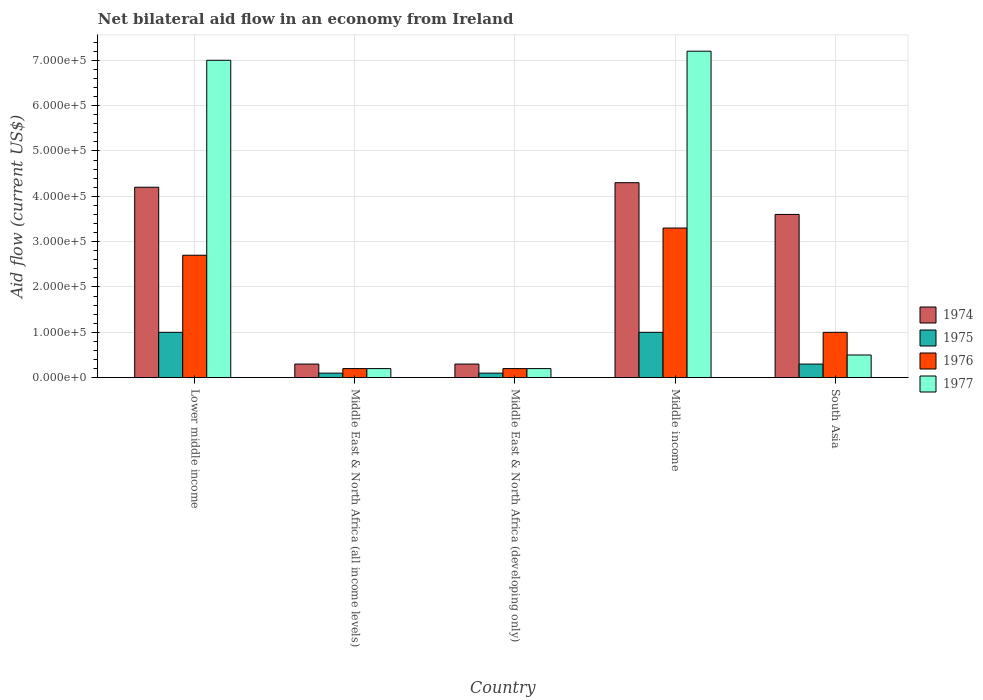How many groups of bars are there?
Provide a succinct answer. 5. Are the number of bars per tick equal to the number of legend labels?
Offer a terse response. Yes. Are the number of bars on each tick of the X-axis equal?
Provide a short and direct response. Yes. How many bars are there on the 5th tick from the left?
Your response must be concise. 4. How many bars are there on the 4th tick from the right?
Offer a very short reply. 4. What is the label of the 2nd group of bars from the left?
Offer a very short reply. Middle East & North Africa (all income levels). Across all countries, what is the maximum net bilateral aid flow in 1976?
Make the answer very short. 3.30e+05. Across all countries, what is the minimum net bilateral aid flow in 1977?
Your answer should be very brief. 2.00e+04. In which country was the net bilateral aid flow in 1975 maximum?
Ensure brevity in your answer.  Lower middle income. In which country was the net bilateral aid flow in 1975 minimum?
Ensure brevity in your answer.  Middle East & North Africa (all income levels). What is the total net bilateral aid flow in 1977 in the graph?
Your response must be concise. 1.51e+06. What is the difference between the net bilateral aid flow in 1977 in Middle East & North Africa (all income levels) and that in Middle income?
Your answer should be very brief. -7.00e+05. What is the difference between the net bilateral aid flow in 1975 in South Asia and the net bilateral aid flow in 1977 in Middle income?
Your answer should be compact. -6.90e+05. What is the average net bilateral aid flow in 1974 per country?
Make the answer very short. 2.54e+05. In how many countries, is the net bilateral aid flow in 1976 greater than 480000 US$?
Offer a terse response. 0. Is the net bilateral aid flow in 1976 in Lower middle income less than that in Middle East & North Africa (developing only)?
Provide a succinct answer. No. What is the difference between the highest and the second highest net bilateral aid flow in 1977?
Offer a terse response. 6.70e+05. Is it the case that in every country, the sum of the net bilateral aid flow in 1975 and net bilateral aid flow in 1977 is greater than the sum of net bilateral aid flow in 1974 and net bilateral aid flow in 1976?
Your answer should be compact. No. What does the 1st bar from the left in Middle East & North Africa (developing only) represents?
Your answer should be compact. 1974. How many bars are there?
Your answer should be very brief. 20. Are all the bars in the graph horizontal?
Ensure brevity in your answer.  No. How many countries are there in the graph?
Provide a short and direct response. 5. What is the difference between two consecutive major ticks on the Y-axis?
Provide a short and direct response. 1.00e+05. Does the graph contain any zero values?
Ensure brevity in your answer.  No. Where does the legend appear in the graph?
Give a very brief answer. Center right. What is the title of the graph?
Give a very brief answer. Net bilateral aid flow in an economy from Ireland. Does "1981" appear as one of the legend labels in the graph?
Your answer should be very brief. No. What is the Aid flow (current US$) in 1975 in Lower middle income?
Offer a very short reply. 1.00e+05. What is the Aid flow (current US$) in 1976 in Lower middle income?
Offer a very short reply. 2.70e+05. What is the Aid flow (current US$) of 1974 in Middle East & North Africa (all income levels)?
Ensure brevity in your answer.  3.00e+04. What is the Aid flow (current US$) of 1975 in Middle East & North Africa (all income levels)?
Provide a short and direct response. 10000. What is the Aid flow (current US$) of 1974 in Middle East & North Africa (developing only)?
Your response must be concise. 3.00e+04. What is the Aid flow (current US$) in 1975 in Middle East & North Africa (developing only)?
Keep it short and to the point. 10000. What is the Aid flow (current US$) of 1976 in Middle East & North Africa (developing only)?
Offer a terse response. 2.00e+04. What is the Aid flow (current US$) of 1977 in Middle East & North Africa (developing only)?
Make the answer very short. 2.00e+04. What is the Aid flow (current US$) in 1975 in Middle income?
Ensure brevity in your answer.  1.00e+05. What is the Aid flow (current US$) of 1977 in Middle income?
Keep it short and to the point. 7.20e+05. What is the Aid flow (current US$) of 1976 in South Asia?
Give a very brief answer. 1.00e+05. Across all countries, what is the maximum Aid flow (current US$) of 1974?
Keep it short and to the point. 4.30e+05. Across all countries, what is the maximum Aid flow (current US$) of 1975?
Offer a very short reply. 1.00e+05. Across all countries, what is the maximum Aid flow (current US$) of 1977?
Your answer should be very brief. 7.20e+05. Across all countries, what is the minimum Aid flow (current US$) of 1975?
Your response must be concise. 10000. Across all countries, what is the minimum Aid flow (current US$) in 1977?
Your answer should be very brief. 2.00e+04. What is the total Aid flow (current US$) of 1974 in the graph?
Your response must be concise. 1.27e+06. What is the total Aid flow (current US$) in 1976 in the graph?
Provide a succinct answer. 7.40e+05. What is the total Aid flow (current US$) in 1977 in the graph?
Keep it short and to the point. 1.51e+06. What is the difference between the Aid flow (current US$) in 1974 in Lower middle income and that in Middle East & North Africa (all income levels)?
Your response must be concise. 3.90e+05. What is the difference between the Aid flow (current US$) of 1975 in Lower middle income and that in Middle East & North Africa (all income levels)?
Keep it short and to the point. 9.00e+04. What is the difference between the Aid flow (current US$) of 1976 in Lower middle income and that in Middle East & North Africa (all income levels)?
Your answer should be very brief. 2.50e+05. What is the difference between the Aid flow (current US$) of 1977 in Lower middle income and that in Middle East & North Africa (all income levels)?
Your answer should be very brief. 6.80e+05. What is the difference between the Aid flow (current US$) of 1977 in Lower middle income and that in Middle East & North Africa (developing only)?
Ensure brevity in your answer.  6.80e+05. What is the difference between the Aid flow (current US$) of 1977 in Lower middle income and that in Middle income?
Provide a succinct answer. -2.00e+04. What is the difference between the Aid flow (current US$) of 1974 in Lower middle income and that in South Asia?
Provide a short and direct response. 6.00e+04. What is the difference between the Aid flow (current US$) of 1976 in Lower middle income and that in South Asia?
Make the answer very short. 1.70e+05. What is the difference between the Aid flow (current US$) in 1977 in Lower middle income and that in South Asia?
Ensure brevity in your answer.  6.50e+05. What is the difference between the Aid flow (current US$) of 1974 in Middle East & North Africa (all income levels) and that in Middle East & North Africa (developing only)?
Your answer should be very brief. 0. What is the difference between the Aid flow (current US$) in 1975 in Middle East & North Africa (all income levels) and that in Middle East & North Africa (developing only)?
Ensure brevity in your answer.  0. What is the difference between the Aid flow (current US$) of 1976 in Middle East & North Africa (all income levels) and that in Middle East & North Africa (developing only)?
Provide a succinct answer. 0. What is the difference between the Aid flow (current US$) of 1974 in Middle East & North Africa (all income levels) and that in Middle income?
Your answer should be compact. -4.00e+05. What is the difference between the Aid flow (current US$) of 1975 in Middle East & North Africa (all income levels) and that in Middle income?
Provide a succinct answer. -9.00e+04. What is the difference between the Aid flow (current US$) in 1976 in Middle East & North Africa (all income levels) and that in Middle income?
Offer a terse response. -3.10e+05. What is the difference between the Aid flow (current US$) of 1977 in Middle East & North Africa (all income levels) and that in Middle income?
Your answer should be compact. -7.00e+05. What is the difference between the Aid flow (current US$) of 1974 in Middle East & North Africa (all income levels) and that in South Asia?
Make the answer very short. -3.30e+05. What is the difference between the Aid flow (current US$) in 1976 in Middle East & North Africa (all income levels) and that in South Asia?
Your answer should be very brief. -8.00e+04. What is the difference between the Aid flow (current US$) in 1974 in Middle East & North Africa (developing only) and that in Middle income?
Provide a succinct answer. -4.00e+05. What is the difference between the Aid flow (current US$) of 1976 in Middle East & North Africa (developing only) and that in Middle income?
Offer a terse response. -3.10e+05. What is the difference between the Aid flow (current US$) in 1977 in Middle East & North Africa (developing only) and that in Middle income?
Your answer should be compact. -7.00e+05. What is the difference between the Aid flow (current US$) of 1974 in Middle East & North Africa (developing only) and that in South Asia?
Provide a short and direct response. -3.30e+05. What is the difference between the Aid flow (current US$) of 1976 in Middle East & North Africa (developing only) and that in South Asia?
Offer a terse response. -8.00e+04. What is the difference between the Aid flow (current US$) of 1974 in Middle income and that in South Asia?
Your answer should be very brief. 7.00e+04. What is the difference between the Aid flow (current US$) in 1975 in Middle income and that in South Asia?
Ensure brevity in your answer.  7.00e+04. What is the difference between the Aid flow (current US$) in 1976 in Middle income and that in South Asia?
Provide a short and direct response. 2.30e+05. What is the difference between the Aid flow (current US$) of 1977 in Middle income and that in South Asia?
Your answer should be very brief. 6.70e+05. What is the difference between the Aid flow (current US$) in 1974 in Lower middle income and the Aid flow (current US$) in 1975 in Middle East & North Africa (all income levels)?
Ensure brevity in your answer.  4.10e+05. What is the difference between the Aid flow (current US$) in 1974 in Lower middle income and the Aid flow (current US$) in 1977 in Middle East & North Africa (all income levels)?
Your answer should be very brief. 4.00e+05. What is the difference between the Aid flow (current US$) of 1975 in Lower middle income and the Aid flow (current US$) of 1976 in Middle East & North Africa (all income levels)?
Provide a short and direct response. 8.00e+04. What is the difference between the Aid flow (current US$) in 1976 in Lower middle income and the Aid flow (current US$) in 1977 in Middle East & North Africa (all income levels)?
Your answer should be compact. 2.50e+05. What is the difference between the Aid flow (current US$) of 1974 in Lower middle income and the Aid flow (current US$) of 1975 in Middle East & North Africa (developing only)?
Your answer should be compact. 4.10e+05. What is the difference between the Aid flow (current US$) of 1976 in Lower middle income and the Aid flow (current US$) of 1977 in Middle East & North Africa (developing only)?
Keep it short and to the point. 2.50e+05. What is the difference between the Aid flow (current US$) of 1974 in Lower middle income and the Aid flow (current US$) of 1975 in Middle income?
Keep it short and to the point. 3.20e+05. What is the difference between the Aid flow (current US$) in 1974 in Lower middle income and the Aid flow (current US$) in 1976 in Middle income?
Provide a short and direct response. 9.00e+04. What is the difference between the Aid flow (current US$) in 1974 in Lower middle income and the Aid flow (current US$) in 1977 in Middle income?
Your response must be concise. -3.00e+05. What is the difference between the Aid flow (current US$) of 1975 in Lower middle income and the Aid flow (current US$) of 1976 in Middle income?
Your response must be concise. -2.30e+05. What is the difference between the Aid flow (current US$) in 1975 in Lower middle income and the Aid flow (current US$) in 1977 in Middle income?
Provide a short and direct response. -6.20e+05. What is the difference between the Aid flow (current US$) in 1976 in Lower middle income and the Aid flow (current US$) in 1977 in Middle income?
Give a very brief answer. -4.50e+05. What is the difference between the Aid flow (current US$) of 1974 in Lower middle income and the Aid flow (current US$) of 1975 in South Asia?
Ensure brevity in your answer.  3.90e+05. What is the difference between the Aid flow (current US$) in 1974 in Lower middle income and the Aid flow (current US$) in 1976 in South Asia?
Offer a terse response. 3.20e+05. What is the difference between the Aid flow (current US$) of 1975 in Lower middle income and the Aid flow (current US$) of 1976 in South Asia?
Offer a terse response. 0. What is the difference between the Aid flow (current US$) in 1974 in Middle East & North Africa (all income levels) and the Aid flow (current US$) in 1975 in Middle East & North Africa (developing only)?
Offer a terse response. 2.00e+04. What is the difference between the Aid flow (current US$) in 1974 in Middle East & North Africa (all income levels) and the Aid flow (current US$) in 1977 in Middle East & North Africa (developing only)?
Offer a terse response. 10000. What is the difference between the Aid flow (current US$) of 1976 in Middle East & North Africa (all income levels) and the Aid flow (current US$) of 1977 in Middle East & North Africa (developing only)?
Ensure brevity in your answer.  0. What is the difference between the Aid flow (current US$) of 1974 in Middle East & North Africa (all income levels) and the Aid flow (current US$) of 1976 in Middle income?
Provide a succinct answer. -3.00e+05. What is the difference between the Aid flow (current US$) of 1974 in Middle East & North Africa (all income levels) and the Aid flow (current US$) of 1977 in Middle income?
Offer a very short reply. -6.90e+05. What is the difference between the Aid flow (current US$) of 1975 in Middle East & North Africa (all income levels) and the Aid flow (current US$) of 1976 in Middle income?
Your answer should be compact. -3.20e+05. What is the difference between the Aid flow (current US$) in 1975 in Middle East & North Africa (all income levels) and the Aid flow (current US$) in 1977 in Middle income?
Make the answer very short. -7.10e+05. What is the difference between the Aid flow (current US$) in 1976 in Middle East & North Africa (all income levels) and the Aid flow (current US$) in 1977 in Middle income?
Offer a very short reply. -7.00e+05. What is the difference between the Aid flow (current US$) of 1975 in Middle East & North Africa (all income levels) and the Aid flow (current US$) of 1976 in South Asia?
Offer a terse response. -9.00e+04. What is the difference between the Aid flow (current US$) of 1975 in Middle East & North Africa (all income levels) and the Aid flow (current US$) of 1977 in South Asia?
Offer a very short reply. -4.00e+04. What is the difference between the Aid flow (current US$) of 1976 in Middle East & North Africa (all income levels) and the Aid flow (current US$) of 1977 in South Asia?
Ensure brevity in your answer.  -3.00e+04. What is the difference between the Aid flow (current US$) of 1974 in Middle East & North Africa (developing only) and the Aid flow (current US$) of 1975 in Middle income?
Make the answer very short. -7.00e+04. What is the difference between the Aid flow (current US$) of 1974 in Middle East & North Africa (developing only) and the Aid flow (current US$) of 1976 in Middle income?
Offer a very short reply. -3.00e+05. What is the difference between the Aid flow (current US$) in 1974 in Middle East & North Africa (developing only) and the Aid flow (current US$) in 1977 in Middle income?
Your response must be concise. -6.90e+05. What is the difference between the Aid flow (current US$) in 1975 in Middle East & North Africa (developing only) and the Aid flow (current US$) in 1976 in Middle income?
Your response must be concise. -3.20e+05. What is the difference between the Aid flow (current US$) in 1975 in Middle East & North Africa (developing only) and the Aid flow (current US$) in 1977 in Middle income?
Provide a short and direct response. -7.10e+05. What is the difference between the Aid flow (current US$) in 1976 in Middle East & North Africa (developing only) and the Aid flow (current US$) in 1977 in Middle income?
Provide a short and direct response. -7.00e+05. What is the difference between the Aid flow (current US$) in 1974 in Middle East & North Africa (developing only) and the Aid flow (current US$) in 1976 in South Asia?
Your response must be concise. -7.00e+04. What is the difference between the Aid flow (current US$) in 1974 in Middle East & North Africa (developing only) and the Aid flow (current US$) in 1977 in South Asia?
Make the answer very short. -2.00e+04. What is the difference between the Aid flow (current US$) of 1975 in Middle East & North Africa (developing only) and the Aid flow (current US$) of 1976 in South Asia?
Your answer should be compact. -9.00e+04. What is the difference between the Aid flow (current US$) in 1975 in Middle East & North Africa (developing only) and the Aid flow (current US$) in 1977 in South Asia?
Your answer should be very brief. -4.00e+04. What is the difference between the Aid flow (current US$) in 1976 in Middle East & North Africa (developing only) and the Aid flow (current US$) in 1977 in South Asia?
Keep it short and to the point. -3.00e+04. What is the difference between the Aid flow (current US$) of 1974 in Middle income and the Aid flow (current US$) of 1975 in South Asia?
Provide a succinct answer. 4.00e+05. What is the difference between the Aid flow (current US$) of 1975 in Middle income and the Aid flow (current US$) of 1976 in South Asia?
Provide a succinct answer. 0. What is the average Aid flow (current US$) of 1974 per country?
Provide a short and direct response. 2.54e+05. What is the average Aid flow (current US$) in 1975 per country?
Provide a succinct answer. 5.00e+04. What is the average Aid flow (current US$) in 1976 per country?
Your answer should be very brief. 1.48e+05. What is the average Aid flow (current US$) in 1977 per country?
Ensure brevity in your answer.  3.02e+05. What is the difference between the Aid flow (current US$) in 1974 and Aid flow (current US$) in 1976 in Lower middle income?
Offer a very short reply. 1.50e+05. What is the difference between the Aid flow (current US$) in 1974 and Aid flow (current US$) in 1977 in Lower middle income?
Your response must be concise. -2.80e+05. What is the difference between the Aid flow (current US$) in 1975 and Aid flow (current US$) in 1977 in Lower middle income?
Make the answer very short. -6.00e+05. What is the difference between the Aid flow (current US$) in 1976 and Aid flow (current US$) in 1977 in Lower middle income?
Keep it short and to the point. -4.30e+05. What is the difference between the Aid flow (current US$) in 1974 and Aid flow (current US$) in 1975 in Middle East & North Africa (all income levels)?
Provide a short and direct response. 2.00e+04. What is the difference between the Aid flow (current US$) in 1974 and Aid flow (current US$) in 1977 in Middle East & North Africa (all income levels)?
Your answer should be very brief. 10000. What is the difference between the Aid flow (current US$) of 1975 and Aid flow (current US$) of 1976 in Middle East & North Africa (all income levels)?
Provide a short and direct response. -10000. What is the difference between the Aid flow (current US$) of 1975 and Aid flow (current US$) of 1977 in Middle East & North Africa (all income levels)?
Make the answer very short. -10000. What is the difference between the Aid flow (current US$) in 1976 and Aid flow (current US$) in 1977 in Middle East & North Africa (all income levels)?
Offer a very short reply. 0. What is the difference between the Aid flow (current US$) of 1974 and Aid flow (current US$) of 1975 in Middle East & North Africa (developing only)?
Offer a very short reply. 2.00e+04. What is the difference between the Aid flow (current US$) of 1974 and Aid flow (current US$) of 1976 in Middle East & North Africa (developing only)?
Provide a succinct answer. 10000. What is the difference between the Aid flow (current US$) in 1974 and Aid flow (current US$) in 1977 in Middle East & North Africa (developing only)?
Make the answer very short. 10000. What is the difference between the Aid flow (current US$) in 1975 and Aid flow (current US$) in 1976 in Middle East & North Africa (developing only)?
Offer a very short reply. -10000. What is the difference between the Aid flow (current US$) of 1975 and Aid flow (current US$) of 1977 in Middle East & North Africa (developing only)?
Make the answer very short. -10000. What is the difference between the Aid flow (current US$) in 1974 and Aid flow (current US$) in 1975 in Middle income?
Offer a very short reply. 3.30e+05. What is the difference between the Aid flow (current US$) in 1974 and Aid flow (current US$) in 1976 in Middle income?
Provide a short and direct response. 1.00e+05. What is the difference between the Aid flow (current US$) in 1974 and Aid flow (current US$) in 1977 in Middle income?
Your answer should be compact. -2.90e+05. What is the difference between the Aid flow (current US$) in 1975 and Aid flow (current US$) in 1976 in Middle income?
Give a very brief answer. -2.30e+05. What is the difference between the Aid flow (current US$) in 1975 and Aid flow (current US$) in 1977 in Middle income?
Give a very brief answer. -6.20e+05. What is the difference between the Aid flow (current US$) in 1976 and Aid flow (current US$) in 1977 in Middle income?
Provide a succinct answer. -3.90e+05. What is the difference between the Aid flow (current US$) of 1974 and Aid flow (current US$) of 1976 in South Asia?
Provide a short and direct response. 2.60e+05. What is the difference between the Aid flow (current US$) of 1974 and Aid flow (current US$) of 1977 in South Asia?
Ensure brevity in your answer.  3.10e+05. What is the difference between the Aid flow (current US$) in 1976 and Aid flow (current US$) in 1977 in South Asia?
Your response must be concise. 5.00e+04. What is the ratio of the Aid flow (current US$) of 1976 in Lower middle income to that in Middle East & North Africa (all income levels)?
Give a very brief answer. 13.5. What is the ratio of the Aid flow (current US$) of 1974 in Lower middle income to that in Middle East & North Africa (developing only)?
Keep it short and to the point. 14. What is the ratio of the Aid flow (current US$) of 1975 in Lower middle income to that in Middle East & North Africa (developing only)?
Ensure brevity in your answer.  10. What is the ratio of the Aid flow (current US$) in 1976 in Lower middle income to that in Middle East & North Africa (developing only)?
Keep it short and to the point. 13.5. What is the ratio of the Aid flow (current US$) in 1977 in Lower middle income to that in Middle East & North Africa (developing only)?
Offer a very short reply. 35. What is the ratio of the Aid flow (current US$) of 1974 in Lower middle income to that in Middle income?
Provide a short and direct response. 0.98. What is the ratio of the Aid flow (current US$) in 1975 in Lower middle income to that in Middle income?
Offer a very short reply. 1. What is the ratio of the Aid flow (current US$) in 1976 in Lower middle income to that in Middle income?
Your answer should be compact. 0.82. What is the ratio of the Aid flow (current US$) of 1977 in Lower middle income to that in Middle income?
Your answer should be compact. 0.97. What is the ratio of the Aid flow (current US$) in 1974 in Lower middle income to that in South Asia?
Keep it short and to the point. 1.17. What is the ratio of the Aid flow (current US$) in 1975 in Lower middle income to that in South Asia?
Offer a terse response. 3.33. What is the ratio of the Aid flow (current US$) in 1974 in Middle East & North Africa (all income levels) to that in Middle East & North Africa (developing only)?
Offer a very short reply. 1. What is the ratio of the Aid flow (current US$) of 1975 in Middle East & North Africa (all income levels) to that in Middle East & North Africa (developing only)?
Your answer should be compact. 1. What is the ratio of the Aid flow (current US$) of 1974 in Middle East & North Africa (all income levels) to that in Middle income?
Your answer should be compact. 0.07. What is the ratio of the Aid flow (current US$) in 1976 in Middle East & North Africa (all income levels) to that in Middle income?
Your answer should be very brief. 0.06. What is the ratio of the Aid flow (current US$) in 1977 in Middle East & North Africa (all income levels) to that in Middle income?
Your answer should be very brief. 0.03. What is the ratio of the Aid flow (current US$) in 1974 in Middle East & North Africa (all income levels) to that in South Asia?
Your answer should be very brief. 0.08. What is the ratio of the Aid flow (current US$) in 1976 in Middle East & North Africa (all income levels) to that in South Asia?
Give a very brief answer. 0.2. What is the ratio of the Aid flow (current US$) of 1974 in Middle East & North Africa (developing only) to that in Middle income?
Give a very brief answer. 0.07. What is the ratio of the Aid flow (current US$) in 1975 in Middle East & North Africa (developing only) to that in Middle income?
Give a very brief answer. 0.1. What is the ratio of the Aid flow (current US$) of 1976 in Middle East & North Africa (developing only) to that in Middle income?
Give a very brief answer. 0.06. What is the ratio of the Aid flow (current US$) in 1977 in Middle East & North Africa (developing only) to that in Middle income?
Make the answer very short. 0.03. What is the ratio of the Aid flow (current US$) of 1974 in Middle East & North Africa (developing only) to that in South Asia?
Keep it short and to the point. 0.08. What is the ratio of the Aid flow (current US$) of 1975 in Middle East & North Africa (developing only) to that in South Asia?
Provide a succinct answer. 0.33. What is the ratio of the Aid flow (current US$) of 1976 in Middle East & North Africa (developing only) to that in South Asia?
Provide a succinct answer. 0.2. What is the ratio of the Aid flow (current US$) of 1977 in Middle East & North Africa (developing only) to that in South Asia?
Provide a succinct answer. 0.4. What is the ratio of the Aid flow (current US$) in 1974 in Middle income to that in South Asia?
Offer a very short reply. 1.19. What is the ratio of the Aid flow (current US$) of 1977 in Middle income to that in South Asia?
Make the answer very short. 14.4. What is the difference between the highest and the lowest Aid flow (current US$) of 1974?
Your response must be concise. 4.00e+05. What is the difference between the highest and the lowest Aid flow (current US$) in 1975?
Your response must be concise. 9.00e+04. What is the difference between the highest and the lowest Aid flow (current US$) in 1976?
Keep it short and to the point. 3.10e+05. 